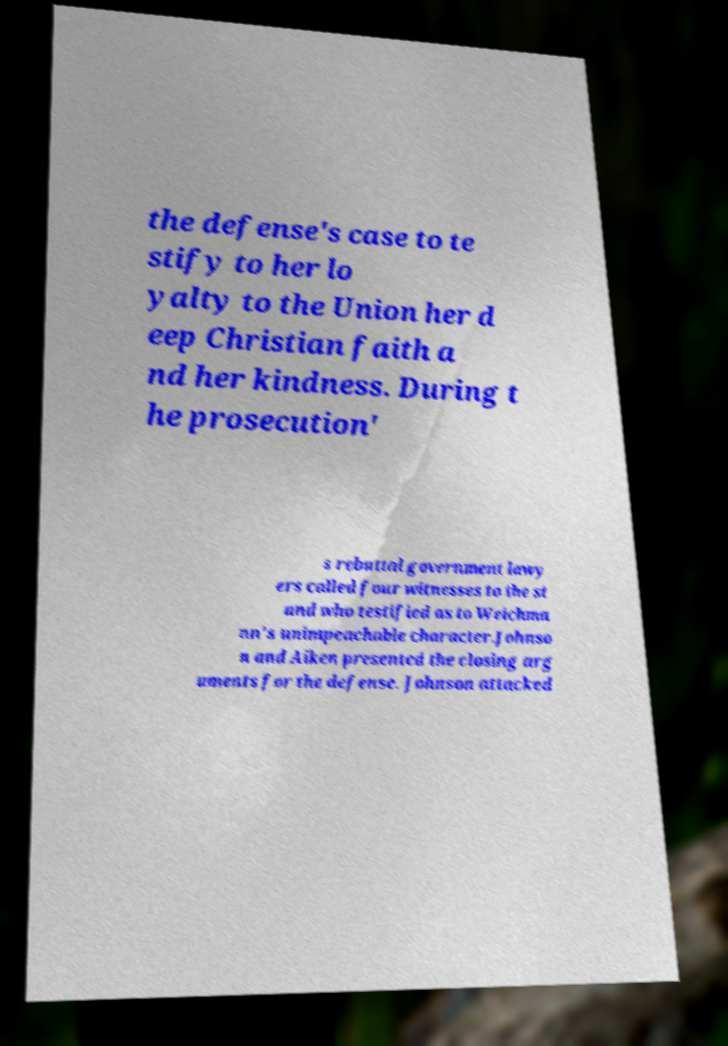For documentation purposes, I need the text within this image transcribed. Could you provide that? the defense's case to te stify to her lo yalty to the Union her d eep Christian faith a nd her kindness. During t he prosecution' s rebuttal government lawy ers called four witnesses to the st and who testified as to Weichma nn's unimpeachable character.Johnso n and Aiken presented the closing arg uments for the defense. Johnson attacked 